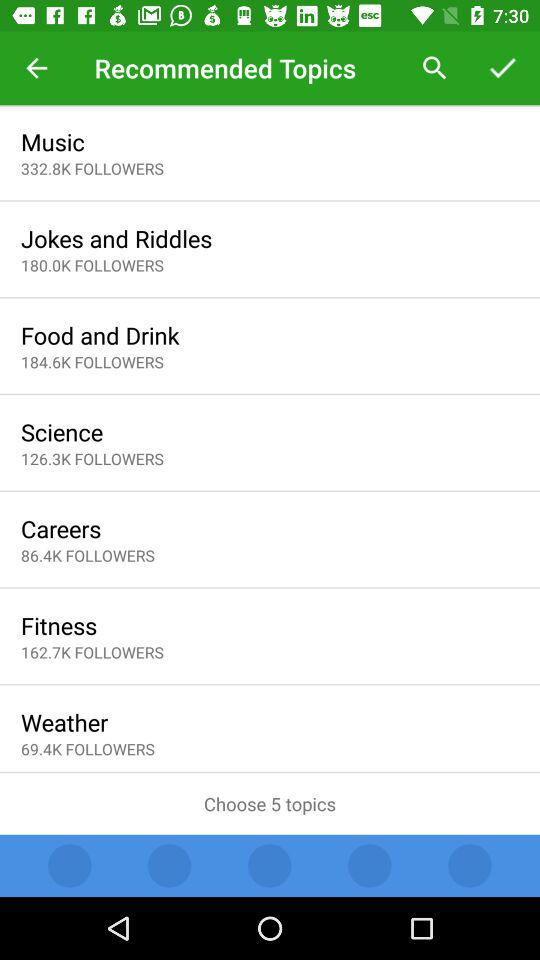What is the total number of followers of "Fitness"? The total number of followers of "Fitness" is 162,700. 